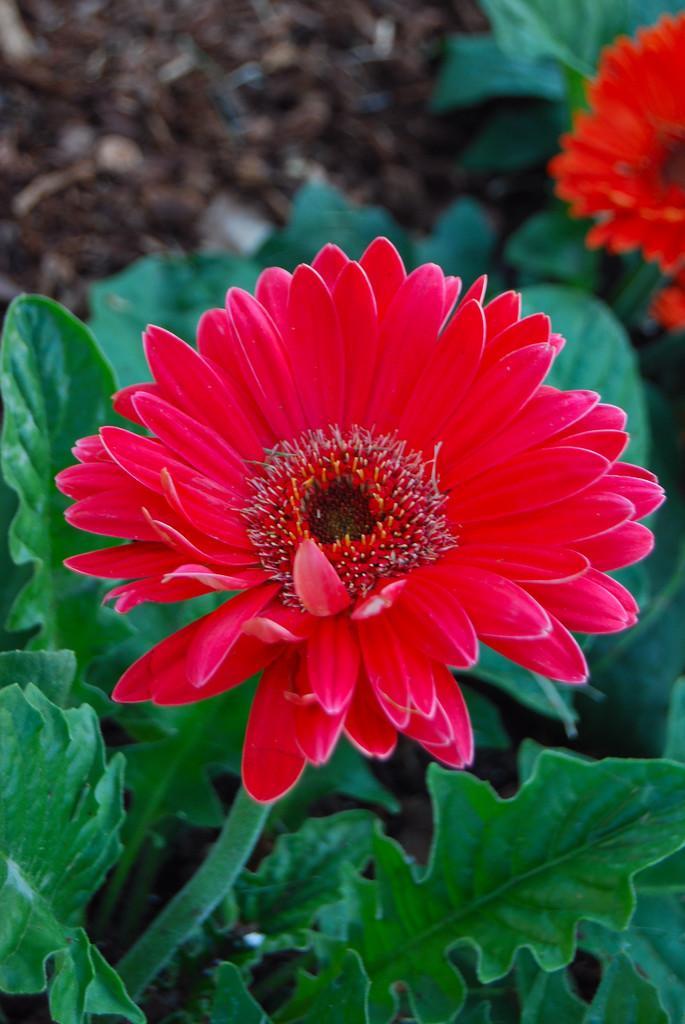Describe this image in one or two sentences. In this image we can see few flowers and plants. 